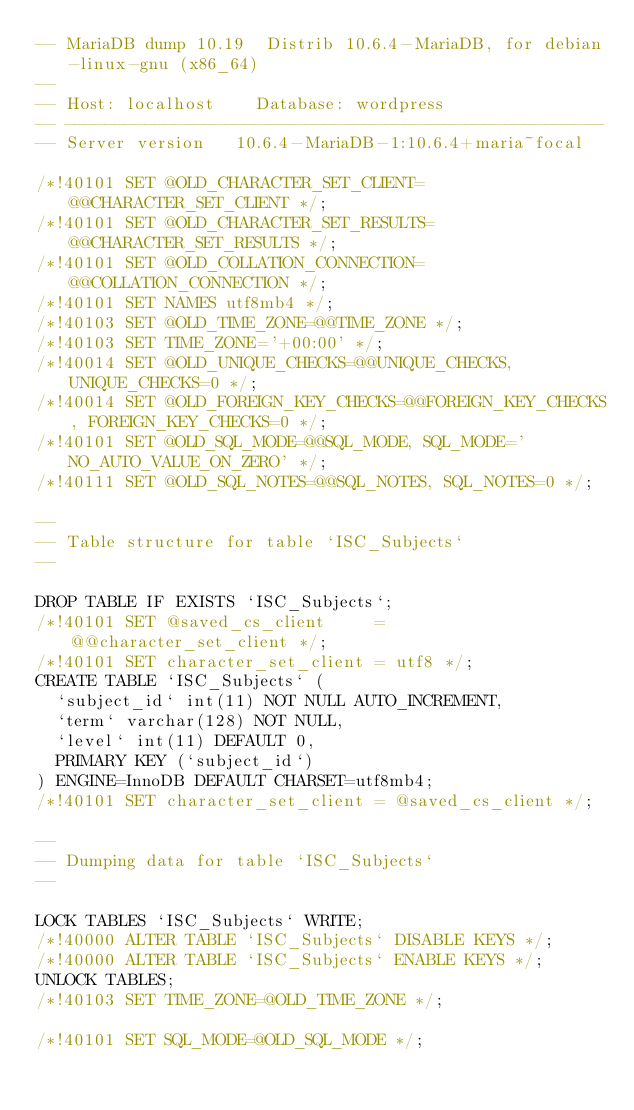<code> <loc_0><loc_0><loc_500><loc_500><_SQL_>-- MariaDB dump 10.19  Distrib 10.6.4-MariaDB, for debian-linux-gnu (x86_64)
--
-- Host: localhost    Database: wordpress
-- ------------------------------------------------------
-- Server version	10.6.4-MariaDB-1:10.6.4+maria~focal

/*!40101 SET @OLD_CHARACTER_SET_CLIENT=@@CHARACTER_SET_CLIENT */;
/*!40101 SET @OLD_CHARACTER_SET_RESULTS=@@CHARACTER_SET_RESULTS */;
/*!40101 SET @OLD_COLLATION_CONNECTION=@@COLLATION_CONNECTION */;
/*!40101 SET NAMES utf8mb4 */;
/*!40103 SET @OLD_TIME_ZONE=@@TIME_ZONE */;
/*!40103 SET TIME_ZONE='+00:00' */;
/*!40014 SET @OLD_UNIQUE_CHECKS=@@UNIQUE_CHECKS, UNIQUE_CHECKS=0 */;
/*!40014 SET @OLD_FOREIGN_KEY_CHECKS=@@FOREIGN_KEY_CHECKS, FOREIGN_KEY_CHECKS=0 */;
/*!40101 SET @OLD_SQL_MODE=@@SQL_MODE, SQL_MODE='NO_AUTO_VALUE_ON_ZERO' */;
/*!40111 SET @OLD_SQL_NOTES=@@SQL_NOTES, SQL_NOTES=0 */;

--
-- Table structure for table `ISC_Subjects`
--

DROP TABLE IF EXISTS `ISC_Subjects`;
/*!40101 SET @saved_cs_client     = @@character_set_client */;
/*!40101 SET character_set_client = utf8 */;
CREATE TABLE `ISC_Subjects` (
  `subject_id` int(11) NOT NULL AUTO_INCREMENT,
  `term` varchar(128) NOT NULL,
  `level` int(11) DEFAULT 0,
  PRIMARY KEY (`subject_id`)
) ENGINE=InnoDB DEFAULT CHARSET=utf8mb4;
/*!40101 SET character_set_client = @saved_cs_client */;

--
-- Dumping data for table `ISC_Subjects`
--

LOCK TABLES `ISC_Subjects` WRITE;
/*!40000 ALTER TABLE `ISC_Subjects` DISABLE KEYS */;
/*!40000 ALTER TABLE `ISC_Subjects` ENABLE KEYS */;
UNLOCK TABLES;
/*!40103 SET TIME_ZONE=@OLD_TIME_ZONE */;

/*!40101 SET SQL_MODE=@OLD_SQL_MODE */;</code> 